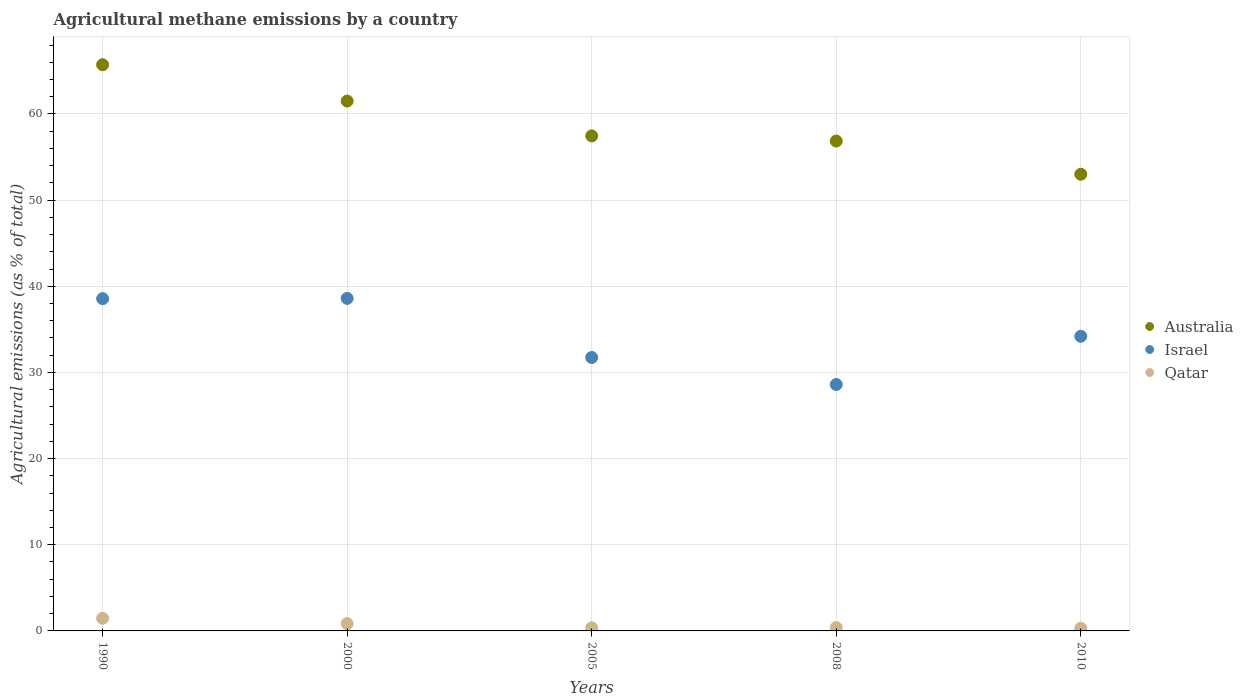What is the amount of agricultural methane emitted in Qatar in 2008?
Offer a very short reply. 0.39. Across all years, what is the maximum amount of agricultural methane emitted in Qatar?
Offer a terse response. 1.46. Across all years, what is the minimum amount of agricultural methane emitted in Australia?
Give a very brief answer. 53. In which year was the amount of agricultural methane emitted in Qatar minimum?
Provide a short and direct response. 2010. What is the total amount of agricultural methane emitted in Israel in the graph?
Your answer should be compact. 171.68. What is the difference between the amount of agricultural methane emitted in Australia in 2000 and that in 2008?
Your response must be concise. 4.64. What is the difference between the amount of agricultural methane emitted in Australia in 1990 and the amount of agricultural methane emitted in Israel in 2000?
Your answer should be compact. 27.11. What is the average amount of agricultural methane emitted in Israel per year?
Provide a succinct answer. 34.34. In the year 2005, what is the difference between the amount of agricultural methane emitted in Qatar and amount of agricultural methane emitted in Israel?
Give a very brief answer. -31.37. In how many years, is the amount of agricultural methane emitted in Australia greater than 30 %?
Keep it short and to the point. 5. What is the ratio of the amount of agricultural methane emitted in Israel in 2005 to that in 2010?
Offer a terse response. 0.93. Is the amount of agricultural methane emitted in Qatar in 1990 less than that in 2000?
Provide a short and direct response. No. Is the difference between the amount of agricultural methane emitted in Qatar in 2000 and 2008 greater than the difference between the amount of agricultural methane emitted in Israel in 2000 and 2008?
Make the answer very short. No. What is the difference between the highest and the second highest amount of agricultural methane emitted in Australia?
Provide a short and direct response. 4.21. What is the difference between the highest and the lowest amount of agricultural methane emitted in Israel?
Offer a very short reply. 10. In how many years, is the amount of agricultural methane emitted in Israel greater than the average amount of agricultural methane emitted in Israel taken over all years?
Give a very brief answer. 2. Is the amount of agricultural methane emitted in Australia strictly less than the amount of agricultural methane emitted in Israel over the years?
Your answer should be very brief. No. What is the difference between two consecutive major ticks on the Y-axis?
Your response must be concise. 10. Are the values on the major ticks of Y-axis written in scientific E-notation?
Your answer should be very brief. No. How many legend labels are there?
Your response must be concise. 3. What is the title of the graph?
Ensure brevity in your answer.  Agricultural methane emissions by a country. Does "Ecuador" appear as one of the legend labels in the graph?
Make the answer very short. No. What is the label or title of the Y-axis?
Provide a succinct answer. Agricultural emissions (as % of total). What is the Agricultural emissions (as % of total) in Australia in 1990?
Your answer should be compact. 65.71. What is the Agricultural emissions (as % of total) of Israel in 1990?
Provide a short and direct response. 38.56. What is the Agricultural emissions (as % of total) of Qatar in 1990?
Your answer should be compact. 1.46. What is the Agricultural emissions (as % of total) of Australia in 2000?
Your answer should be compact. 61.5. What is the Agricultural emissions (as % of total) in Israel in 2000?
Offer a terse response. 38.59. What is the Agricultural emissions (as % of total) in Qatar in 2000?
Your answer should be very brief. 0.85. What is the Agricultural emissions (as % of total) of Australia in 2005?
Ensure brevity in your answer.  57.45. What is the Agricultural emissions (as % of total) of Israel in 2005?
Your answer should be compact. 31.73. What is the Agricultural emissions (as % of total) in Qatar in 2005?
Your answer should be very brief. 0.36. What is the Agricultural emissions (as % of total) in Australia in 2008?
Provide a short and direct response. 56.85. What is the Agricultural emissions (as % of total) in Israel in 2008?
Provide a succinct answer. 28.6. What is the Agricultural emissions (as % of total) in Qatar in 2008?
Offer a very short reply. 0.39. What is the Agricultural emissions (as % of total) in Australia in 2010?
Offer a terse response. 53. What is the Agricultural emissions (as % of total) of Israel in 2010?
Make the answer very short. 34.19. What is the Agricultural emissions (as % of total) in Qatar in 2010?
Keep it short and to the point. 0.31. Across all years, what is the maximum Agricultural emissions (as % of total) in Australia?
Ensure brevity in your answer.  65.71. Across all years, what is the maximum Agricultural emissions (as % of total) of Israel?
Offer a very short reply. 38.59. Across all years, what is the maximum Agricultural emissions (as % of total) of Qatar?
Keep it short and to the point. 1.46. Across all years, what is the minimum Agricultural emissions (as % of total) of Australia?
Your answer should be very brief. 53. Across all years, what is the minimum Agricultural emissions (as % of total) in Israel?
Offer a very short reply. 28.6. Across all years, what is the minimum Agricultural emissions (as % of total) in Qatar?
Your response must be concise. 0.31. What is the total Agricultural emissions (as % of total) in Australia in the graph?
Your answer should be very brief. 294.51. What is the total Agricultural emissions (as % of total) of Israel in the graph?
Your response must be concise. 171.68. What is the total Agricultural emissions (as % of total) of Qatar in the graph?
Make the answer very short. 3.38. What is the difference between the Agricultural emissions (as % of total) in Australia in 1990 and that in 2000?
Provide a short and direct response. 4.21. What is the difference between the Agricultural emissions (as % of total) in Israel in 1990 and that in 2000?
Your answer should be very brief. -0.03. What is the difference between the Agricultural emissions (as % of total) in Qatar in 1990 and that in 2000?
Ensure brevity in your answer.  0.61. What is the difference between the Agricultural emissions (as % of total) of Australia in 1990 and that in 2005?
Offer a terse response. 8.26. What is the difference between the Agricultural emissions (as % of total) of Israel in 1990 and that in 2005?
Provide a succinct answer. 6.83. What is the difference between the Agricultural emissions (as % of total) in Qatar in 1990 and that in 2005?
Give a very brief answer. 1.1. What is the difference between the Agricultural emissions (as % of total) of Australia in 1990 and that in 2008?
Your answer should be very brief. 8.85. What is the difference between the Agricultural emissions (as % of total) of Israel in 1990 and that in 2008?
Provide a short and direct response. 9.96. What is the difference between the Agricultural emissions (as % of total) in Qatar in 1990 and that in 2008?
Provide a short and direct response. 1.07. What is the difference between the Agricultural emissions (as % of total) of Australia in 1990 and that in 2010?
Ensure brevity in your answer.  12.71. What is the difference between the Agricultural emissions (as % of total) of Israel in 1990 and that in 2010?
Ensure brevity in your answer.  4.37. What is the difference between the Agricultural emissions (as % of total) of Qatar in 1990 and that in 2010?
Offer a very short reply. 1.15. What is the difference between the Agricultural emissions (as % of total) in Australia in 2000 and that in 2005?
Keep it short and to the point. 4.04. What is the difference between the Agricultural emissions (as % of total) in Israel in 2000 and that in 2005?
Keep it short and to the point. 6.86. What is the difference between the Agricultural emissions (as % of total) in Qatar in 2000 and that in 2005?
Your response must be concise. 0.49. What is the difference between the Agricultural emissions (as % of total) of Australia in 2000 and that in 2008?
Give a very brief answer. 4.64. What is the difference between the Agricultural emissions (as % of total) in Israel in 2000 and that in 2008?
Give a very brief answer. 10. What is the difference between the Agricultural emissions (as % of total) in Qatar in 2000 and that in 2008?
Give a very brief answer. 0.46. What is the difference between the Agricultural emissions (as % of total) of Australia in 2000 and that in 2010?
Your answer should be very brief. 8.5. What is the difference between the Agricultural emissions (as % of total) of Israel in 2000 and that in 2010?
Offer a terse response. 4.4. What is the difference between the Agricultural emissions (as % of total) of Qatar in 2000 and that in 2010?
Your response must be concise. 0.54. What is the difference between the Agricultural emissions (as % of total) of Australia in 2005 and that in 2008?
Keep it short and to the point. 0.6. What is the difference between the Agricultural emissions (as % of total) in Israel in 2005 and that in 2008?
Your answer should be very brief. 3.14. What is the difference between the Agricultural emissions (as % of total) in Qatar in 2005 and that in 2008?
Offer a terse response. -0.03. What is the difference between the Agricultural emissions (as % of total) in Australia in 2005 and that in 2010?
Your response must be concise. 4.45. What is the difference between the Agricultural emissions (as % of total) in Israel in 2005 and that in 2010?
Your response must be concise. -2.46. What is the difference between the Agricultural emissions (as % of total) in Qatar in 2005 and that in 2010?
Provide a short and direct response. 0.05. What is the difference between the Agricultural emissions (as % of total) in Australia in 2008 and that in 2010?
Your answer should be very brief. 3.86. What is the difference between the Agricultural emissions (as % of total) in Israel in 2008 and that in 2010?
Provide a short and direct response. -5.59. What is the difference between the Agricultural emissions (as % of total) in Qatar in 2008 and that in 2010?
Offer a very short reply. 0.08. What is the difference between the Agricultural emissions (as % of total) in Australia in 1990 and the Agricultural emissions (as % of total) in Israel in 2000?
Ensure brevity in your answer.  27.11. What is the difference between the Agricultural emissions (as % of total) of Australia in 1990 and the Agricultural emissions (as % of total) of Qatar in 2000?
Ensure brevity in your answer.  64.86. What is the difference between the Agricultural emissions (as % of total) of Israel in 1990 and the Agricultural emissions (as % of total) of Qatar in 2000?
Offer a very short reply. 37.71. What is the difference between the Agricultural emissions (as % of total) in Australia in 1990 and the Agricultural emissions (as % of total) in Israel in 2005?
Your answer should be compact. 33.97. What is the difference between the Agricultural emissions (as % of total) in Australia in 1990 and the Agricultural emissions (as % of total) in Qatar in 2005?
Keep it short and to the point. 65.35. What is the difference between the Agricultural emissions (as % of total) of Israel in 1990 and the Agricultural emissions (as % of total) of Qatar in 2005?
Offer a terse response. 38.2. What is the difference between the Agricultural emissions (as % of total) of Australia in 1990 and the Agricultural emissions (as % of total) of Israel in 2008?
Give a very brief answer. 37.11. What is the difference between the Agricultural emissions (as % of total) of Australia in 1990 and the Agricultural emissions (as % of total) of Qatar in 2008?
Give a very brief answer. 65.32. What is the difference between the Agricultural emissions (as % of total) in Israel in 1990 and the Agricultural emissions (as % of total) in Qatar in 2008?
Your response must be concise. 38.17. What is the difference between the Agricultural emissions (as % of total) of Australia in 1990 and the Agricultural emissions (as % of total) of Israel in 2010?
Ensure brevity in your answer.  31.52. What is the difference between the Agricultural emissions (as % of total) of Australia in 1990 and the Agricultural emissions (as % of total) of Qatar in 2010?
Ensure brevity in your answer.  65.4. What is the difference between the Agricultural emissions (as % of total) of Israel in 1990 and the Agricultural emissions (as % of total) of Qatar in 2010?
Provide a short and direct response. 38.25. What is the difference between the Agricultural emissions (as % of total) in Australia in 2000 and the Agricultural emissions (as % of total) in Israel in 2005?
Your answer should be very brief. 29.76. What is the difference between the Agricultural emissions (as % of total) of Australia in 2000 and the Agricultural emissions (as % of total) of Qatar in 2005?
Give a very brief answer. 61.13. What is the difference between the Agricultural emissions (as % of total) in Israel in 2000 and the Agricultural emissions (as % of total) in Qatar in 2005?
Offer a terse response. 38.23. What is the difference between the Agricultural emissions (as % of total) of Australia in 2000 and the Agricultural emissions (as % of total) of Israel in 2008?
Make the answer very short. 32.9. What is the difference between the Agricultural emissions (as % of total) of Australia in 2000 and the Agricultural emissions (as % of total) of Qatar in 2008?
Ensure brevity in your answer.  61.11. What is the difference between the Agricultural emissions (as % of total) in Israel in 2000 and the Agricultural emissions (as % of total) in Qatar in 2008?
Offer a terse response. 38.21. What is the difference between the Agricultural emissions (as % of total) of Australia in 2000 and the Agricultural emissions (as % of total) of Israel in 2010?
Provide a succinct answer. 27.3. What is the difference between the Agricultural emissions (as % of total) in Australia in 2000 and the Agricultural emissions (as % of total) in Qatar in 2010?
Keep it short and to the point. 61.18. What is the difference between the Agricultural emissions (as % of total) of Israel in 2000 and the Agricultural emissions (as % of total) of Qatar in 2010?
Ensure brevity in your answer.  38.28. What is the difference between the Agricultural emissions (as % of total) of Australia in 2005 and the Agricultural emissions (as % of total) of Israel in 2008?
Make the answer very short. 28.85. What is the difference between the Agricultural emissions (as % of total) in Australia in 2005 and the Agricultural emissions (as % of total) in Qatar in 2008?
Provide a short and direct response. 57.06. What is the difference between the Agricultural emissions (as % of total) in Israel in 2005 and the Agricultural emissions (as % of total) in Qatar in 2008?
Keep it short and to the point. 31.35. What is the difference between the Agricultural emissions (as % of total) of Australia in 2005 and the Agricultural emissions (as % of total) of Israel in 2010?
Your answer should be compact. 23.26. What is the difference between the Agricultural emissions (as % of total) in Australia in 2005 and the Agricultural emissions (as % of total) in Qatar in 2010?
Offer a very short reply. 57.14. What is the difference between the Agricultural emissions (as % of total) in Israel in 2005 and the Agricultural emissions (as % of total) in Qatar in 2010?
Give a very brief answer. 31.42. What is the difference between the Agricultural emissions (as % of total) of Australia in 2008 and the Agricultural emissions (as % of total) of Israel in 2010?
Your response must be concise. 22.66. What is the difference between the Agricultural emissions (as % of total) of Australia in 2008 and the Agricultural emissions (as % of total) of Qatar in 2010?
Provide a short and direct response. 56.54. What is the difference between the Agricultural emissions (as % of total) of Israel in 2008 and the Agricultural emissions (as % of total) of Qatar in 2010?
Offer a terse response. 28.29. What is the average Agricultural emissions (as % of total) of Australia per year?
Your answer should be compact. 58.9. What is the average Agricultural emissions (as % of total) in Israel per year?
Offer a very short reply. 34.34. What is the average Agricultural emissions (as % of total) of Qatar per year?
Provide a short and direct response. 0.68. In the year 1990, what is the difference between the Agricultural emissions (as % of total) in Australia and Agricultural emissions (as % of total) in Israel?
Give a very brief answer. 27.15. In the year 1990, what is the difference between the Agricultural emissions (as % of total) of Australia and Agricultural emissions (as % of total) of Qatar?
Your answer should be compact. 64.25. In the year 1990, what is the difference between the Agricultural emissions (as % of total) in Israel and Agricultural emissions (as % of total) in Qatar?
Provide a succinct answer. 37.1. In the year 2000, what is the difference between the Agricultural emissions (as % of total) of Australia and Agricultural emissions (as % of total) of Israel?
Provide a succinct answer. 22.9. In the year 2000, what is the difference between the Agricultural emissions (as % of total) in Australia and Agricultural emissions (as % of total) in Qatar?
Your response must be concise. 60.65. In the year 2000, what is the difference between the Agricultural emissions (as % of total) of Israel and Agricultural emissions (as % of total) of Qatar?
Your response must be concise. 37.75. In the year 2005, what is the difference between the Agricultural emissions (as % of total) in Australia and Agricultural emissions (as % of total) in Israel?
Provide a succinct answer. 25.72. In the year 2005, what is the difference between the Agricultural emissions (as % of total) of Australia and Agricultural emissions (as % of total) of Qatar?
Your answer should be compact. 57.09. In the year 2005, what is the difference between the Agricultural emissions (as % of total) in Israel and Agricultural emissions (as % of total) in Qatar?
Provide a short and direct response. 31.37. In the year 2008, what is the difference between the Agricultural emissions (as % of total) in Australia and Agricultural emissions (as % of total) in Israel?
Your answer should be compact. 28.26. In the year 2008, what is the difference between the Agricultural emissions (as % of total) in Australia and Agricultural emissions (as % of total) in Qatar?
Your response must be concise. 56.47. In the year 2008, what is the difference between the Agricultural emissions (as % of total) of Israel and Agricultural emissions (as % of total) of Qatar?
Your answer should be very brief. 28.21. In the year 2010, what is the difference between the Agricultural emissions (as % of total) in Australia and Agricultural emissions (as % of total) in Israel?
Give a very brief answer. 18.81. In the year 2010, what is the difference between the Agricultural emissions (as % of total) in Australia and Agricultural emissions (as % of total) in Qatar?
Keep it short and to the point. 52.69. In the year 2010, what is the difference between the Agricultural emissions (as % of total) in Israel and Agricultural emissions (as % of total) in Qatar?
Make the answer very short. 33.88. What is the ratio of the Agricultural emissions (as % of total) of Australia in 1990 to that in 2000?
Offer a very short reply. 1.07. What is the ratio of the Agricultural emissions (as % of total) in Qatar in 1990 to that in 2000?
Ensure brevity in your answer.  1.72. What is the ratio of the Agricultural emissions (as % of total) in Australia in 1990 to that in 2005?
Your answer should be very brief. 1.14. What is the ratio of the Agricultural emissions (as % of total) in Israel in 1990 to that in 2005?
Ensure brevity in your answer.  1.22. What is the ratio of the Agricultural emissions (as % of total) in Qatar in 1990 to that in 2005?
Your answer should be compact. 4.04. What is the ratio of the Agricultural emissions (as % of total) of Australia in 1990 to that in 2008?
Provide a succinct answer. 1.16. What is the ratio of the Agricultural emissions (as % of total) of Israel in 1990 to that in 2008?
Provide a succinct answer. 1.35. What is the ratio of the Agricultural emissions (as % of total) of Qatar in 1990 to that in 2008?
Your response must be concise. 3.76. What is the ratio of the Agricultural emissions (as % of total) of Australia in 1990 to that in 2010?
Your answer should be very brief. 1.24. What is the ratio of the Agricultural emissions (as % of total) in Israel in 1990 to that in 2010?
Offer a terse response. 1.13. What is the ratio of the Agricultural emissions (as % of total) in Qatar in 1990 to that in 2010?
Offer a very short reply. 4.69. What is the ratio of the Agricultural emissions (as % of total) of Australia in 2000 to that in 2005?
Your answer should be compact. 1.07. What is the ratio of the Agricultural emissions (as % of total) in Israel in 2000 to that in 2005?
Your response must be concise. 1.22. What is the ratio of the Agricultural emissions (as % of total) in Qatar in 2000 to that in 2005?
Give a very brief answer. 2.34. What is the ratio of the Agricultural emissions (as % of total) of Australia in 2000 to that in 2008?
Provide a short and direct response. 1.08. What is the ratio of the Agricultural emissions (as % of total) of Israel in 2000 to that in 2008?
Your response must be concise. 1.35. What is the ratio of the Agricultural emissions (as % of total) in Qatar in 2000 to that in 2008?
Offer a very short reply. 2.18. What is the ratio of the Agricultural emissions (as % of total) in Australia in 2000 to that in 2010?
Ensure brevity in your answer.  1.16. What is the ratio of the Agricultural emissions (as % of total) in Israel in 2000 to that in 2010?
Offer a very short reply. 1.13. What is the ratio of the Agricultural emissions (as % of total) in Qatar in 2000 to that in 2010?
Your response must be concise. 2.72. What is the ratio of the Agricultural emissions (as % of total) in Australia in 2005 to that in 2008?
Give a very brief answer. 1.01. What is the ratio of the Agricultural emissions (as % of total) in Israel in 2005 to that in 2008?
Your answer should be very brief. 1.11. What is the ratio of the Agricultural emissions (as % of total) of Qatar in 2005 to that in 2008?
Provide a succinct answer. 0.93. What is the ratio of the Agricultural emissions (as % of total) in Australia in 2005 to that in 2010?
Your answer should be very brief. 1.08. What is the ratio of the Agricultural emissions (as % of total) of Israel in 2005 to that in 2010?
Give a very brief answer. 0.93. What is the ratio of the Agricultural emissions (as % of total) in Qatar in 2005 to that in 2010?
Provide a short and direct response. 1.16. What is the ratio of the Agricultural emissions (as % of total) of Australia in 2008 to that in 2010?
Make the answer very short. 1.07. What is the ratio of the Agricultural emissions (as % of total) of Israel in 2008 to that in 2010?
Make the answer very short. 0.84. What is the ratio of the Agricultural emissions (as % of total) of Qatar in 2008 to that in 2010?
Make the answer very short. 1.25. What is the difference between the highest and the second highest Agricultural emissions (as % of total) in Australia?
Give a very brief answer. 4.21. What is the difference between the highest and the second highest Agricultural emissions (as % of total) of Israel?
Offer a terse response. 0.03. What is the difference between the highest and the second highest Agricultural emissions (as % of total) of Qatar?
Your response must be concise. 0.61. What is the difference between the highest and the lowest Agricultural emissions (as % of total) of Australia?
Keep it short and to the point. 12.71. What is the difference between the highest and the lowest Agricultural emissions (as % of total) in Israel?
Make the answer very short. 10. What is the difference between the highest and the lowest Agricultural emissions (as % of total) in Qatar?
Make the answer very short. 1.15. 